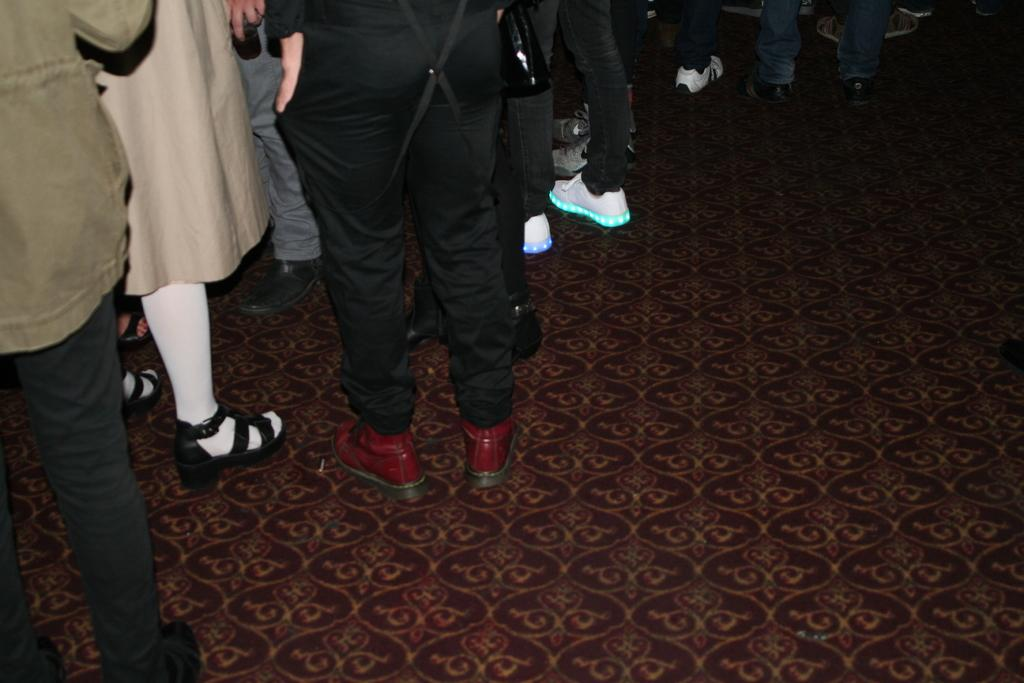What can be seen at the bottom of the image? There are legs of people visible in the image. Where are the legs located? The legs are on the floor. What type of current can be seen flowing through the legs in the image? There is no current visible in the image; it only shows legs of people on the floor. 